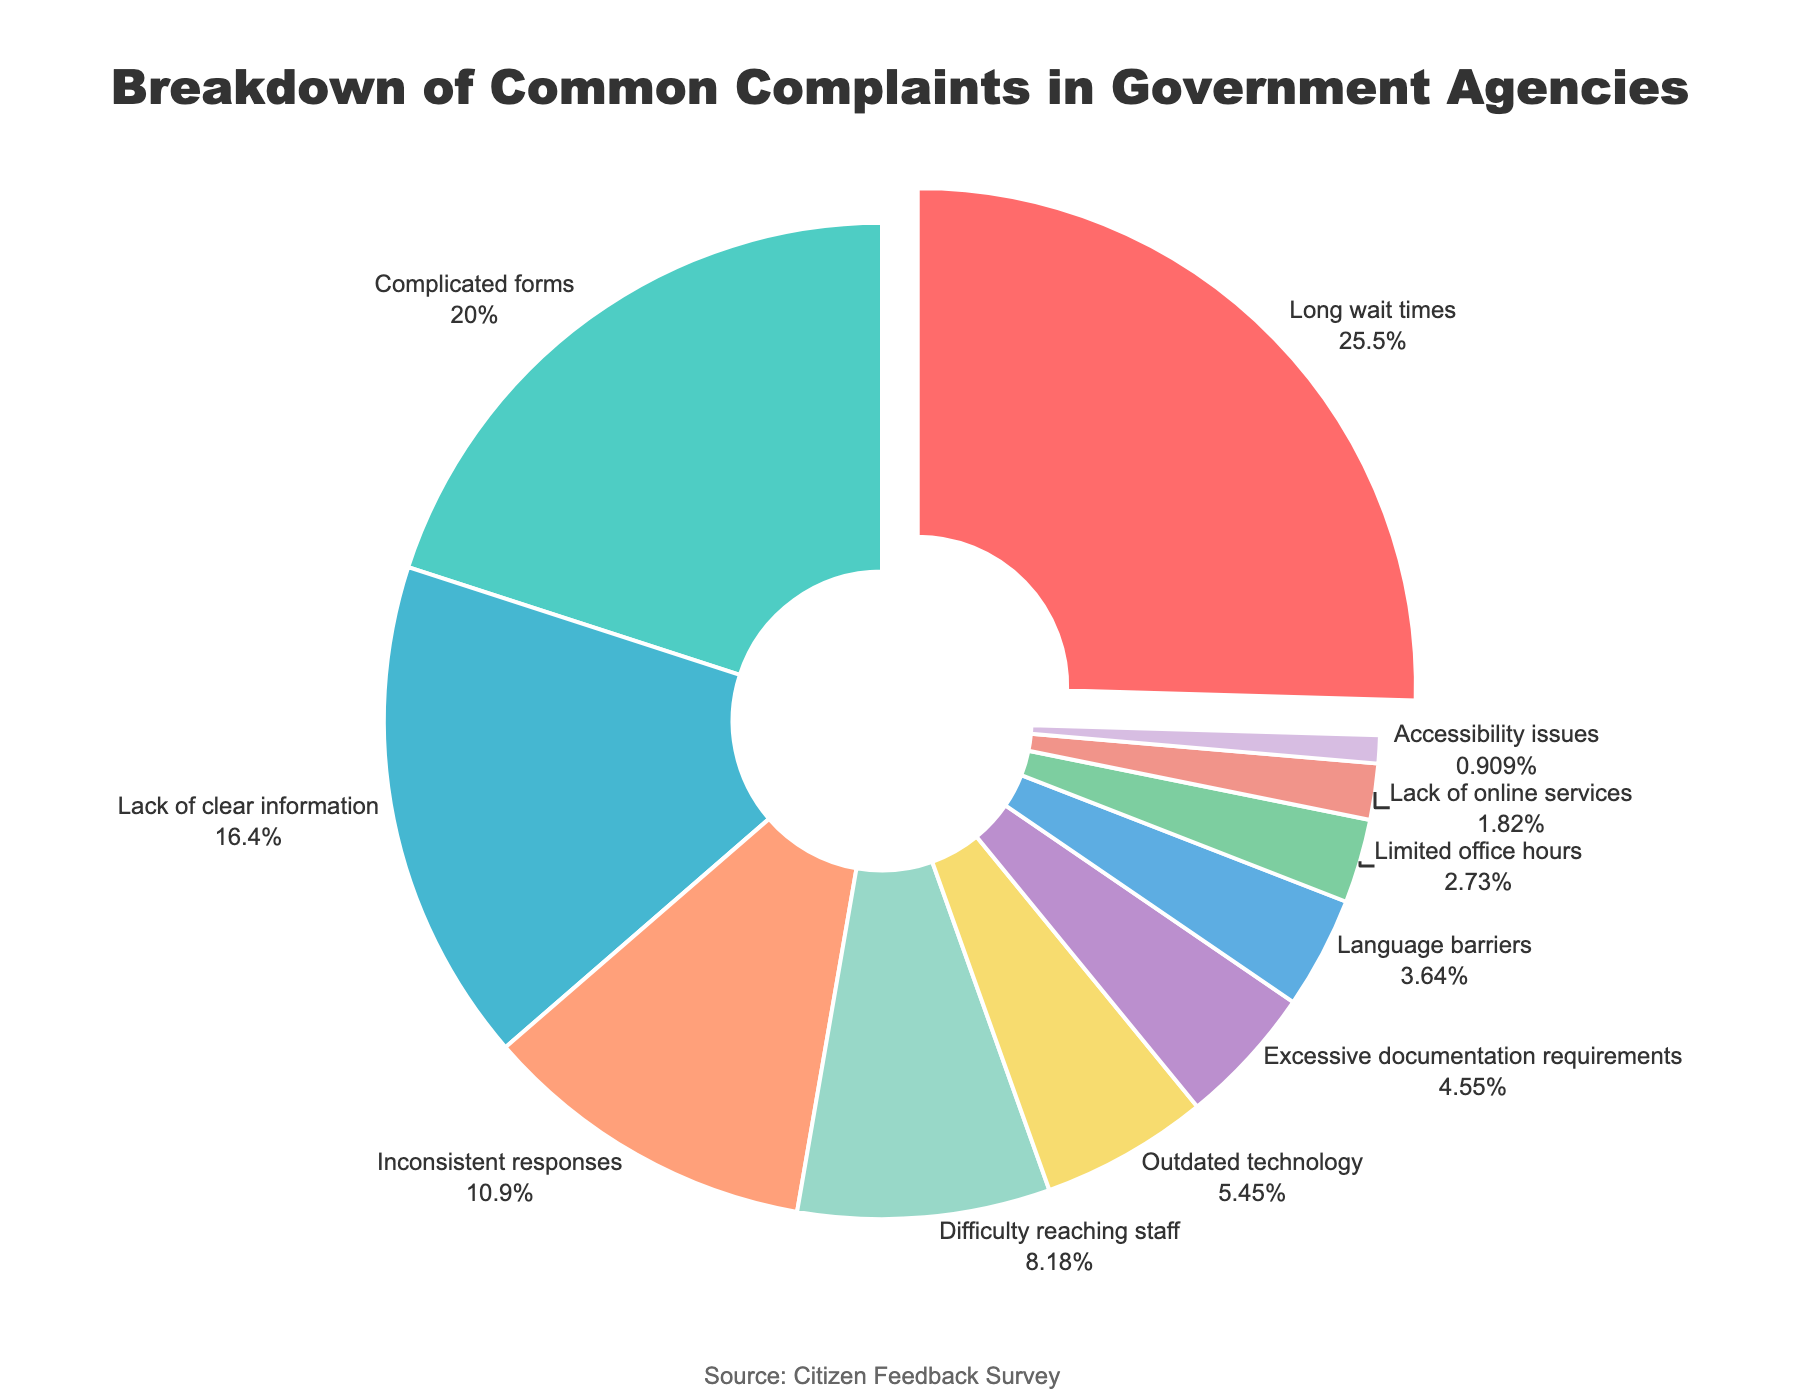What's the largest category of complaints? The figure highlights that the 'Long wait times' category is pulled out slightly from the rest, and it shows the largest segment with 28%.
Answer: Long wait times Which two categories together account for more than 45% of the complaints? 'Long wait times' (28%) and 'Complicated forms' (22%) together make up 50% of the total complaints, exceeding 45%.
Answer: Long wait times and Complicated forms What's the difference in percentage between 'Inconsistent responses' and 'Outdated technology'? 'Inconsistent responses' comprise 12% and 'Outdated technology' 6%, which means the difference is 12% - 6% = 6%.
Answer: 6% Which category has the least percentage of complaints and what is that percentage? The smallest segment in the pie chart is labeled 'Accessibility issues' and it shows 1%.
Answer: Accessibility issues, 1% How much more prevalent is 'Difficulty reaching staff' compared to 'Limited office hours'? 'Difficulty reaching staff' is 9% while 'Limited office hours' is 3%, thus 'Difficulty reaching staff' is 9% - 3% = 6% more prevalent.
Answer: 6% What is the combined percentage of 'Lack of online services' and 'Language barriers'? 'Lack of online services' accounts for 2% and 'Language barriers' for 4%, summing up to 2% + 4% = 6%.
Answer: 6% Which color represents the segment for 'Lack of clear information' and what percentage does it cover? The segment for 'Lack of clear information' is shown in green, covering 18%.
Answer: Green, 18% How many categories have a percentage of complaints higher than 10%? 'Long wait times' (28%), 'Complicated forms' (22%), and 'Lack of clear information' (18%), and 'Inconsistent responses' (12%) all have percentages higher than 10%.
Answer: 4 Which category representing the smallest portion is directly to the right of 'Lack of clear information'? 'Accessibility issues' is the segment directly to the right of 'Lack of clear information' and has the smallest portion with 1%.
Answer: Accessibility issues 